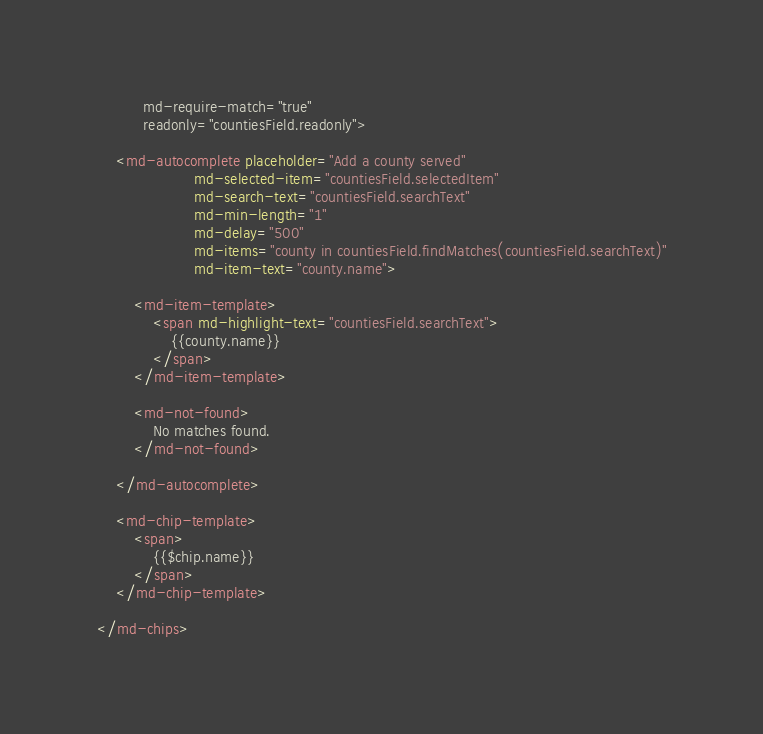Convert code to text. <code><loc_0><loc_0><loc_500><loc_500><_HTML_>          md-require-match="true"
          readonly="countiesField.readonly">

    <md-autocomplete placeholder="Add a county served"
                     md-selected-item="countiesField.selectedItem"
                     md-search-text="countiesField.searchText"
                     md-min-length="1"
                     md-delay="500"
                     md-items="county in countiesField.findMatches(countiesField.searchText)"
                     md-item-text="county.name">

        <md-item-template>
            <span md-highlight-text="countiesField.searchText">
                {{county.name}}
            </span>
        </md-item-template>

        <md-not-found>
            No matches found.
        </md-not-found>

    </md-autocomplete>

    <md-chip-template>
        <span>
            {{$chip.name}}
        </span>
    </md-chip-template>

</md-chips>
</code> 